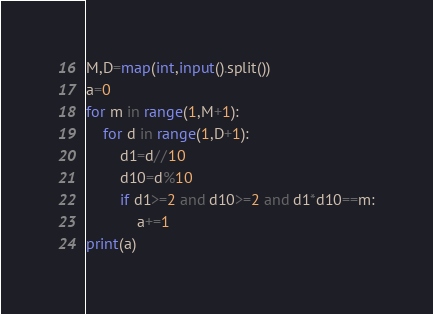<code> <loc_0><loc_0><loc_500><loc_500><_Python_>M,D=map(int,input().split())
a=0
for m in range(1,M+1):
    for d in range(1,D+1):
        d1=d//10
        d10=d%10
        if d1>=2 and d10>=2 and d1*d10==m:
            a+=1
print(a)</code> 